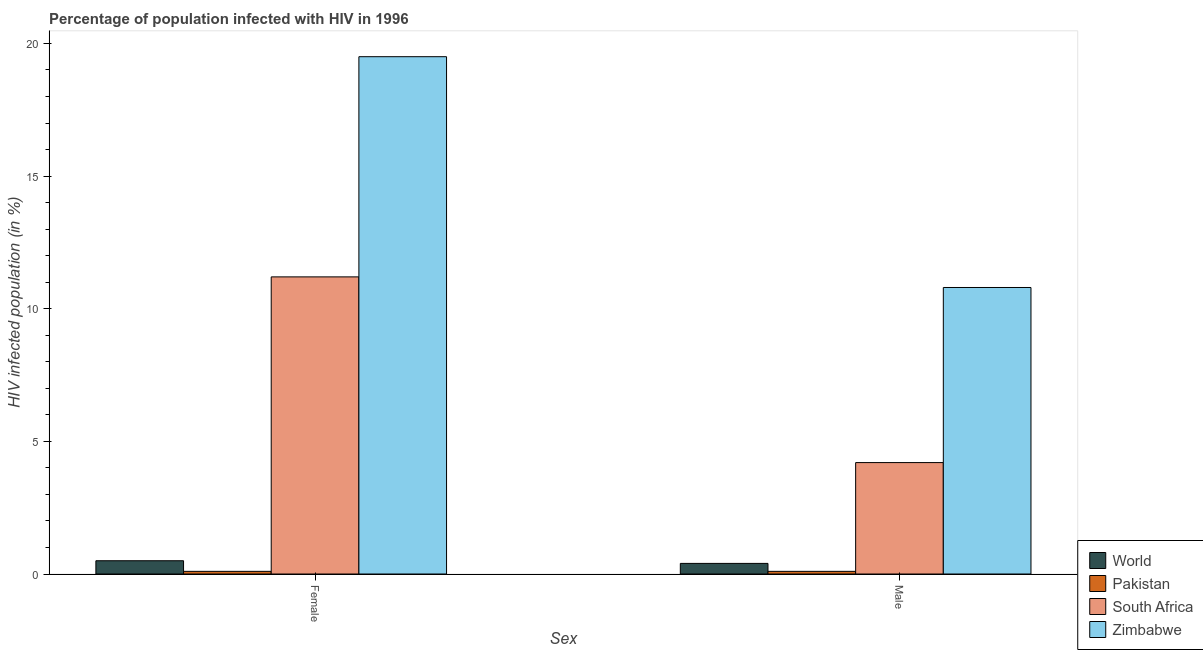How many different coloured bars are there?
Your response must be concise. 4. How many bars are there on the 2nd tick from the left?
Provide a succinct answer. 4. What is the label of the 1st group of bars from the left?
Ensure brevity in your answer.  Female. What is the percentage of males who are infected with hiv in Pakistan?
Your response must be concise. 0.1. Across all countries, what is the minimum percentage of females who are infected with hiv?
Your answer should be compact. 0.1. In which country was the percentage of females who are infected with hiv maximum?
Give a very brief answer. Zimbabwe. In which country was the percentage of females who are infected with hiv minimum?
Offer a terse response. Pakistan. What is the difference between the percentage of males who are infected with hiv in Zimbabwe and that in Pakistan?
Provide a short and direct response. 10.7. What is the average percentage of males who are infected with hiv per country?
Your response must be concise. 3.88. What is the difference between the percentage of females who are infected with hiv and percentage of males who are infected with hiv in South Africa?
Give a very brief answer. 7. What is the ratio of the percentage of males who are infected with hiv in Zimbabwe to that in World?
Your answer should be compact. 27. Is the percentage of males who are infected with hiv in World less than that in South Africa?
Your answer should be compact. Yes. In how many countries, is the percentage of males who are infected with hiv greater than the average percentage of males who are infected with hiv taken over all countries?
Offer a terse response. 2. What does the 3rd bar from the left in Female represents?
Offer a very short reply. South Africa. What does the 1st bar from the right in Male represents?
Offer a terse response. Zimbabwe. Are all the bars in the graph horizontal?
Your answer should be very brief. No. What is the difference between two consecutive major ticks on the Y-axis?
Provide a succinct answer. 5. Are the values on the major ticks of Y-axis written in scientific E-notation?
Your answer should be very brief. No. Where does the legend appear in the graph?
Make the answer very short. Bottom right. How many legend labels are there?
Your answer should be compact. 4. What is the title of the graph?
Provide a short and direct response. Percentage of population infected with HIV in 1996. What is the label or title of the X-axis?
Ensure brevity in your answer.  Sex. What is the label or title of the Y-axis?
Provide a succinct answer. HIV infected population (in %). What is the HIV infected population (in %) in South Africa in Female?
Offer a terse response. 11.2. What is the HIV infected population (in %) of Pakistan in Male?
Give a very brief answer. 0.1. Across all Sex, what is the maximum HIV infected population (in %) in World?
Ensure brevity in your answer.  0.5. Across all Sex, what is the maximum HIV infected population (in %) of South Africa?
Keep it short and to the point. 11.2. Across all Sex, what is the maximum HIV infected population (in %) in Zimbabwe?
Make the answer very short. 19.5. Across all Sex, what is the minimum HIV infected population (in %) in World?
Make the answer very short. 0.4. Across all Sex, what is the minimum HIV infected population (in %) of South Africa?
Your response must be concise. 4.2. Across all Sex, what is the minimum HIV infected population (in %) in Zimbabwe?
Make the answer very short. 10.8. What is the total HIV infected population (in %) of Zimbabwe in the graph?
Ensure brevity in your answer.  30.3. What is the difference between the HIV infected population (in %) in World in Female and that in Male?
Offer a very short reply. 0.1. What is the difference between the HIV infected population (in %) of South Africa in Female and that in Male?
Ensure brevity in your answer.  7. What is the difference between the HIV infected population (in %) of World in Female and the HIV infected population (in %) of Pakistan in Male?
Make the answer very short. 0.4. What is the difference between the HIV infected population (in %) of World in Female and the HIV infected population (in %) of South Africa in Male?
Ensure brevity in your answer.  -3.7. What is the difference between the HIV infected population (in %) in Pakistan in Female and the HIV infected population (in %) in South Africa in Male?
Give a very brief answer. -4.1. What is the difference between the HIV infected population (in %) in Pakistan in Female and the HIV infected population (in %) in Zimbabwe in Male?
Your answer should be very brief. -10.7. What is the average HIV infected population (in %) of World per Sex?
Offer a terse response. 0.45. What is the average HIV infected population (in %) of Pakistan per Sex?
Provide a succinct answer. 0.1. What is the average HIV infected population (in %) of Zimbabwe per Sex?
Offer a very short reply. 15.15. What is the difference between the HIV infected population (in %) of World and HIV infected population (in %) of Pakistan in Female?
Keep it short and to the point. 0.4. What is the difference between the HIV infected population (in %) of World and HIV infected population (in %) of Zimbabwe in Female?
Ensure brevity in your answer.  -19. What is the difference between the HIV infected population (in %) of Pakistan and HIV infected population (in %) of South Africa in Female?
Offer a terse response. -11.1. What is the difference between the HIV infected population (in %) in Pakistan and HIV infected population (in %) in Zimbabwe in Female?
Make the answer very short. -19.4. What is the difference between the HIV infected population (in %) in South Africa and HIV infected population (in %) in Zimbabwe in Female?
Offer a terse response. -8.3. What is the difference between the HIV infected population (in %) in World and HIV infected population (in %) in Pakistan in Male?
Ensure brevity in your answer.  0.3. What is the difference between the HIV infected population (in %) of World and HIV infected population (in %) of South Africa in Male?
Offer a very short reply. -3.8. What is the difference between the HIV infected population (in %) of South Africa and HIV infected population (in %) of Zimbabwe in Male?
Offer a terse response. -6.6. What is the ratio of the HIV infected population (in %) in South Africa in Female to that in Male?
Your answer should be very brief. 2.67. What is the ratio of the HIV infected population (in %) of Zimbabwe in Female to that in Male?
Provide a short and direct response. 1.81. What is the difference between the highest and the second highest HIV infected population (in %) of Pakistan?
Keep it short and to the point. 0. What is the difference between the highest and the second highest HIV infected population (in %) of Zimbabwe?
Your answer should be compact. 8.7. What is the difference between the highest and the lowest HIV infected population (in %) in World?
Your answer should be very brief. 0.1. 